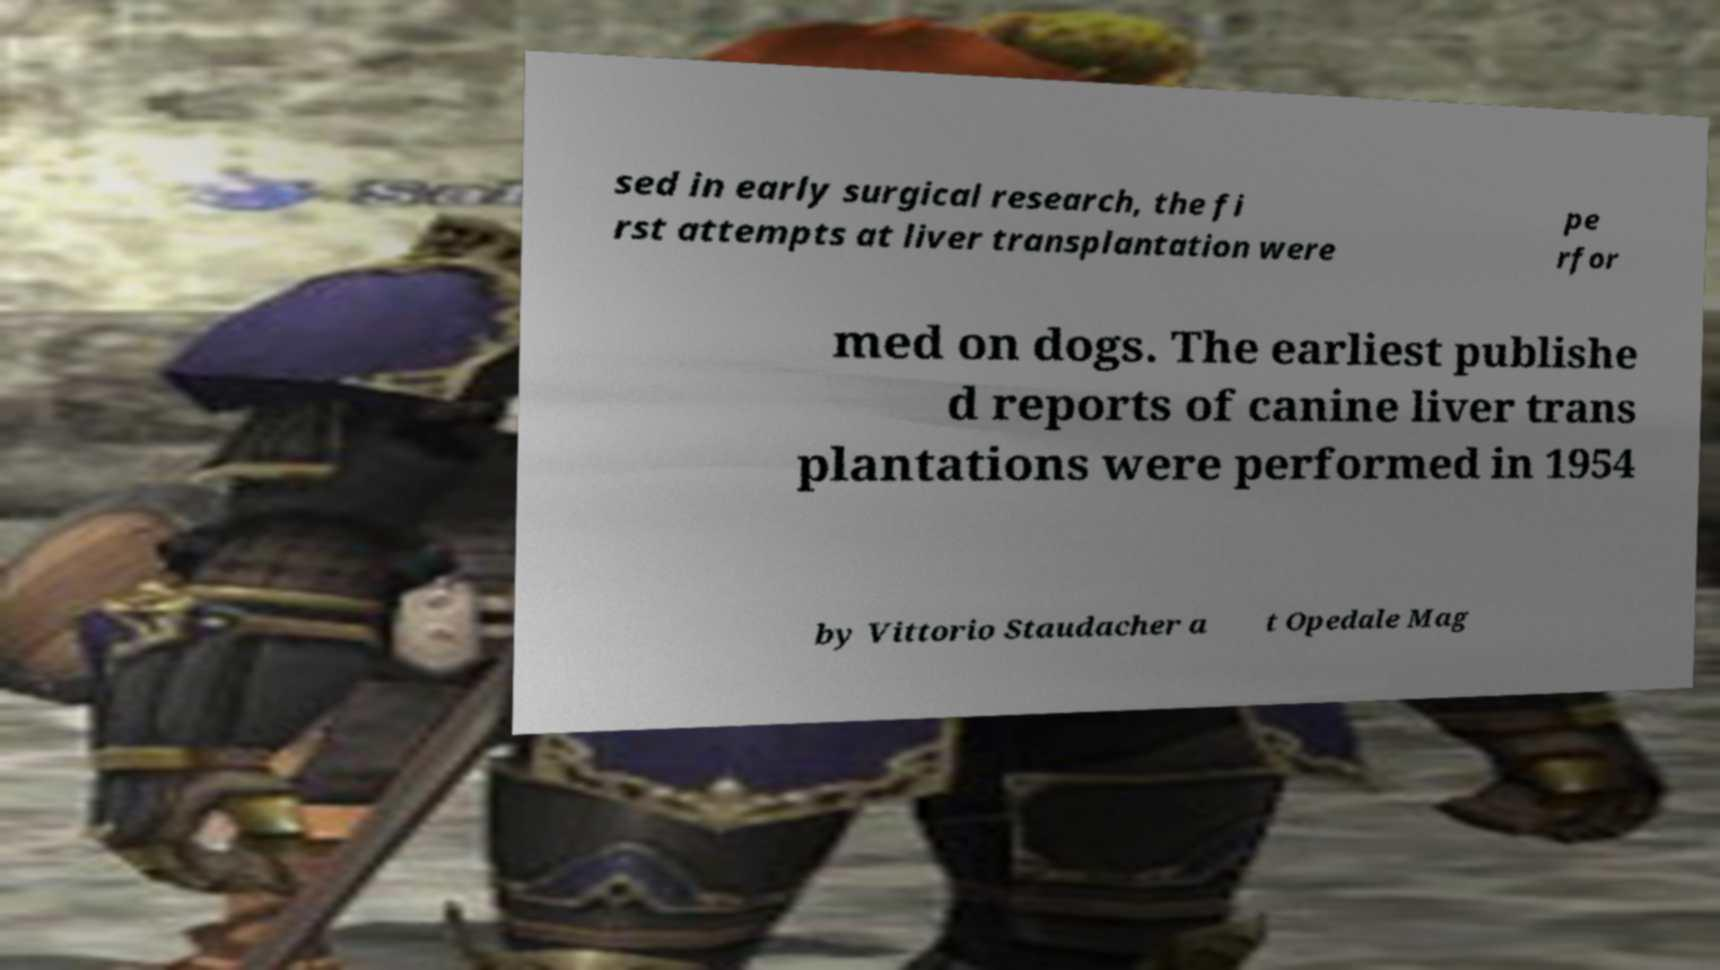Could you extract and type out the text from this image? sed in early surgical research, the fi rst attempts at liver transplantation were pe rfor med on dogs. The earliest publishe d reports of canine liver trans plantations were performed in 1954 by Vittorio Staudacher a t Opedale Mag 